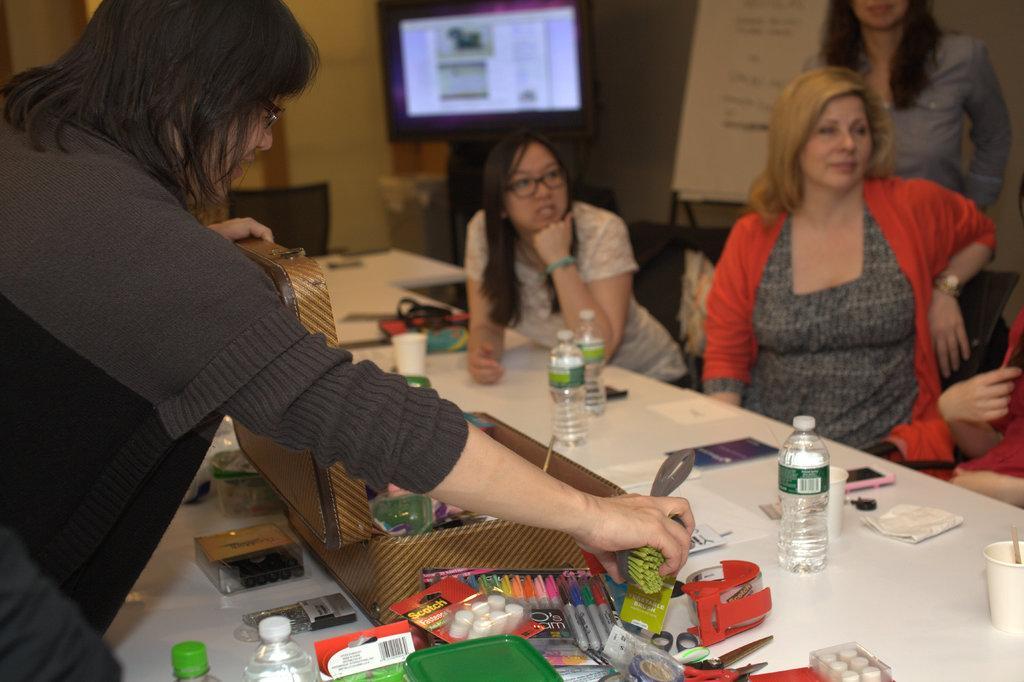Describe this image in one or two sentences. In this image, we can see a group of people. Few people are sitting and two people are standing. In the middle of the image, we can see so many things and objects are placed on it. Here a woman is holding an object. Background we can see wall, screen, banners, chair, dustbin and few objects. 